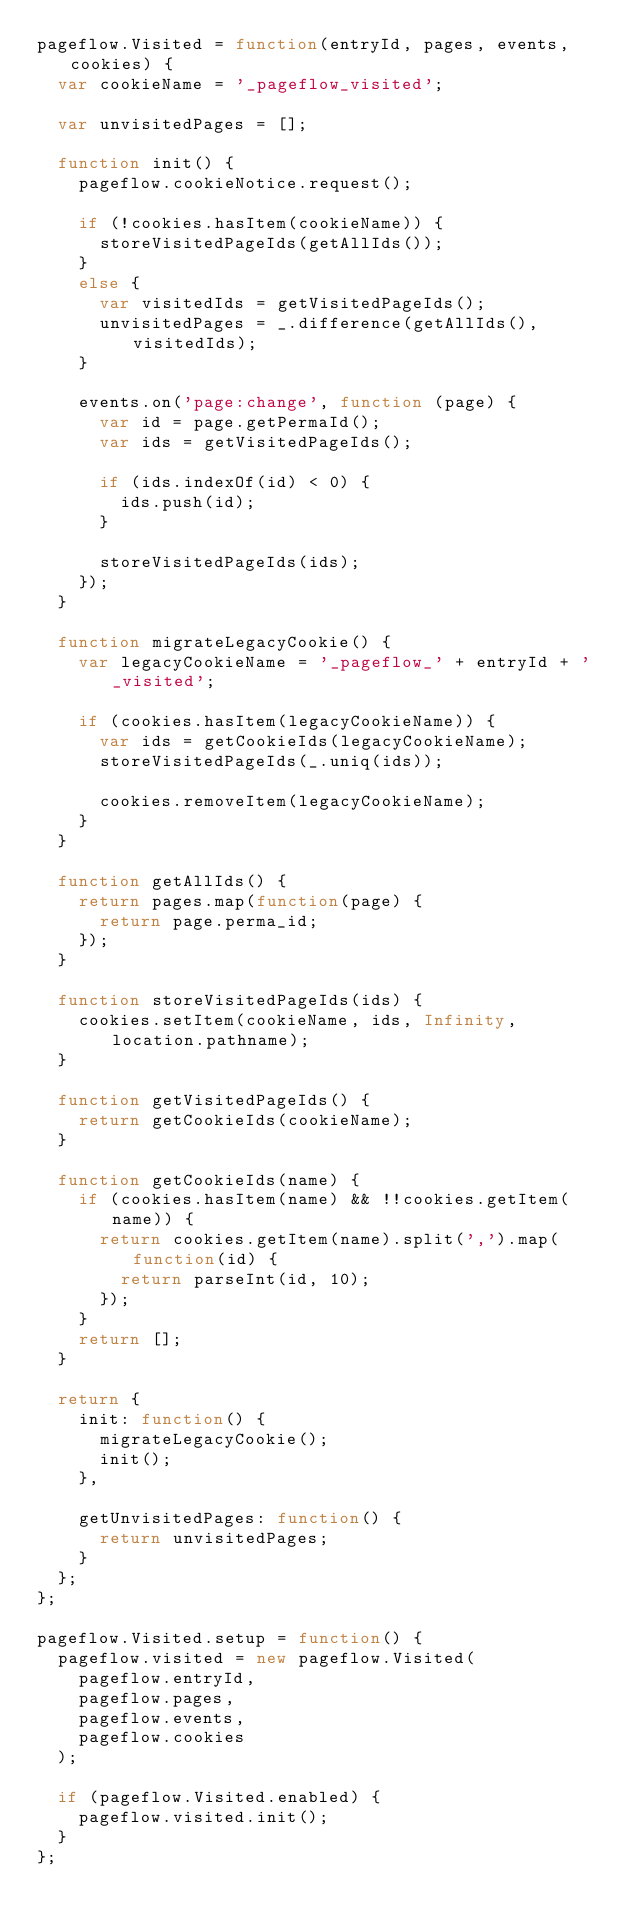Convert code to text. <code><loc_0><loc_0><loc_500><loc_500><_JavaScript_>pageflow.Visited = function(entryId, pages, events, cookies) {
  var cookieName = '_pageflow_visited';

  var unvisitedPages = [];

  function init() {
    pageflow.cookieNotice.request();

    if (!cookies.hasItem(cookieName)) {
      storeVisitedPageIds(getAllIds());
    }
    else {
      var visitedIds = getVisitedPageIds();
      unvisitedPages = _.difference(getAllIds(), visitedIds);
    }

    events.on('page:change', function (page) {
      var id = page.getPermaId();
      var ids = getVisitedPageIds();

      if (ids.indexOf(id) < 0) {
        ids.push(id);
      }

      storeVisitedPageIds(ids);
    });
  }

  function migrateLegacyCookie() {
    var legacyCookieName = '_pageflow_' + entryId + '_visited';

    if (cookies.hasItem(legacyCookieName)) {
      var ids = getCookieIds(legacyCookieName);
      storeVisitedPageIds(_.uniq(ids));

      cookies.removeItem(legacyCookieName);
    }
  }

  function getAllIds() {
    return pages.map(function(page) {
      return page.perma_id;
    });
  }

  function storeVisitedPageIds(ids) {
    cookies.setItem(cookieName, ids, Infinity, location.pathname);
  }

  function getVisitedPageIds() {
    return getCookieIds(cookieName);
  }

  function getCookieIds(name) {
    if (cookies.hasItem(name) && !!cookies.getItem(name)) {
      return cookies.getItem(name).split(',').map(function(id) {
        return parseInt(id, 10);
      });
    }
    return [];
  }

  return {
    init: function() {
      migrateLegacyCookie();
      init();
    },

    getUnvisitedPages: function() {
      return unvisitedPages;
    }
  };
};

pageflow.Visited.setup = function() {
  pageflow.visited = new pageflow.Visited(
    pageflow.entryId,
    pageflow.pages,
    pageflow.events,
    pageflow.cookies
  );

  if (pageflow.Visited.enabled) {
    pageflow.visited.init();
  }
};
</code> 